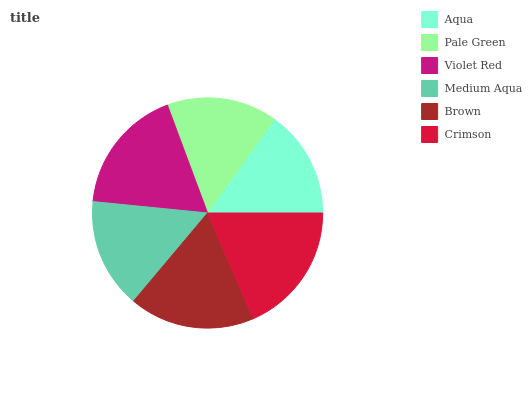Is Aqua the minimum?
Answer yes or no. Yes. Is Crimson the maximum?
Answer yes or no. Yes. Is Pale Green the minimum?
Answer yes or no. No. Is Pale Green the maximum?
Answer yes or no. No. Is Pale Green greater than Aqua?
Answer yes or no. Yes. Is Aqua less than Pale Green?
Answer yes or no. Yes. Is Aqua greater than Pale Green?
Answer yes or no. No. Is Pale Green less than Aqua?
Answer yes or no. No. Is Brown the high median?
Answer yes or no. Yes. Is Pale Green the low median?
Answer yes or no. Yes. Is Aqua the high median?
Answer yes or no. No. Is Medium Aqua the low median?
Answer yes or no. No. 